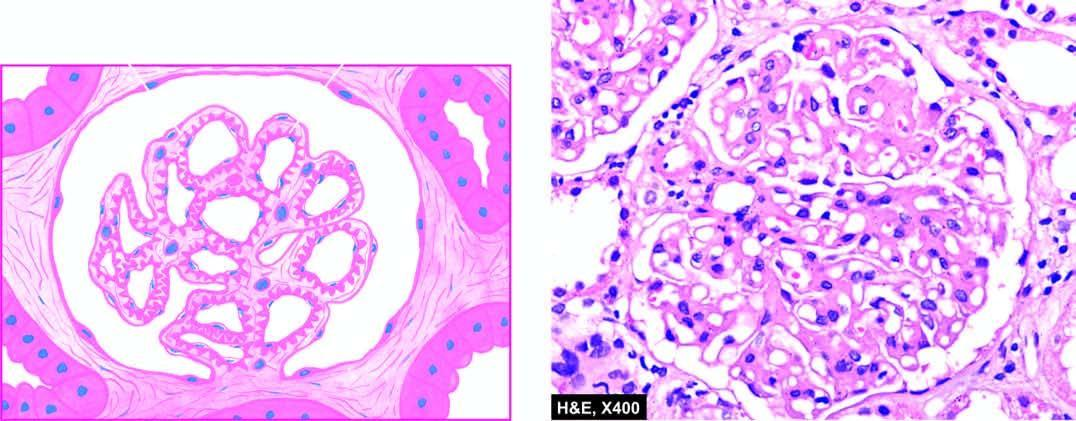what are normocellular?
Answer the question using a single word or phrase. Glomeruli 